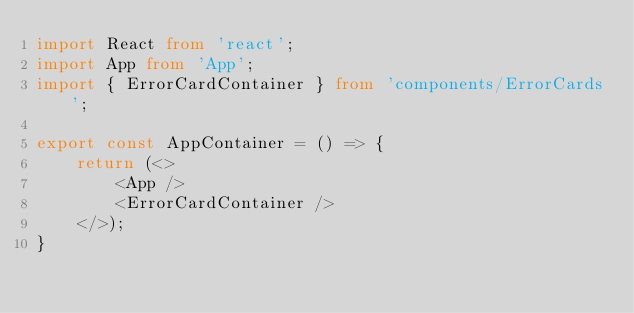<code> <loc_0><loc_0><loc_500><loc_500><_TypeScript_>import React from 'react';
import App from 'App';
import { ErrorCardContainer } from 'components/ErrorCards';

export const AppContainer = () => {
    return (<>
        <App />
        <ErrorCardContainer />
    </>);
}</code> 